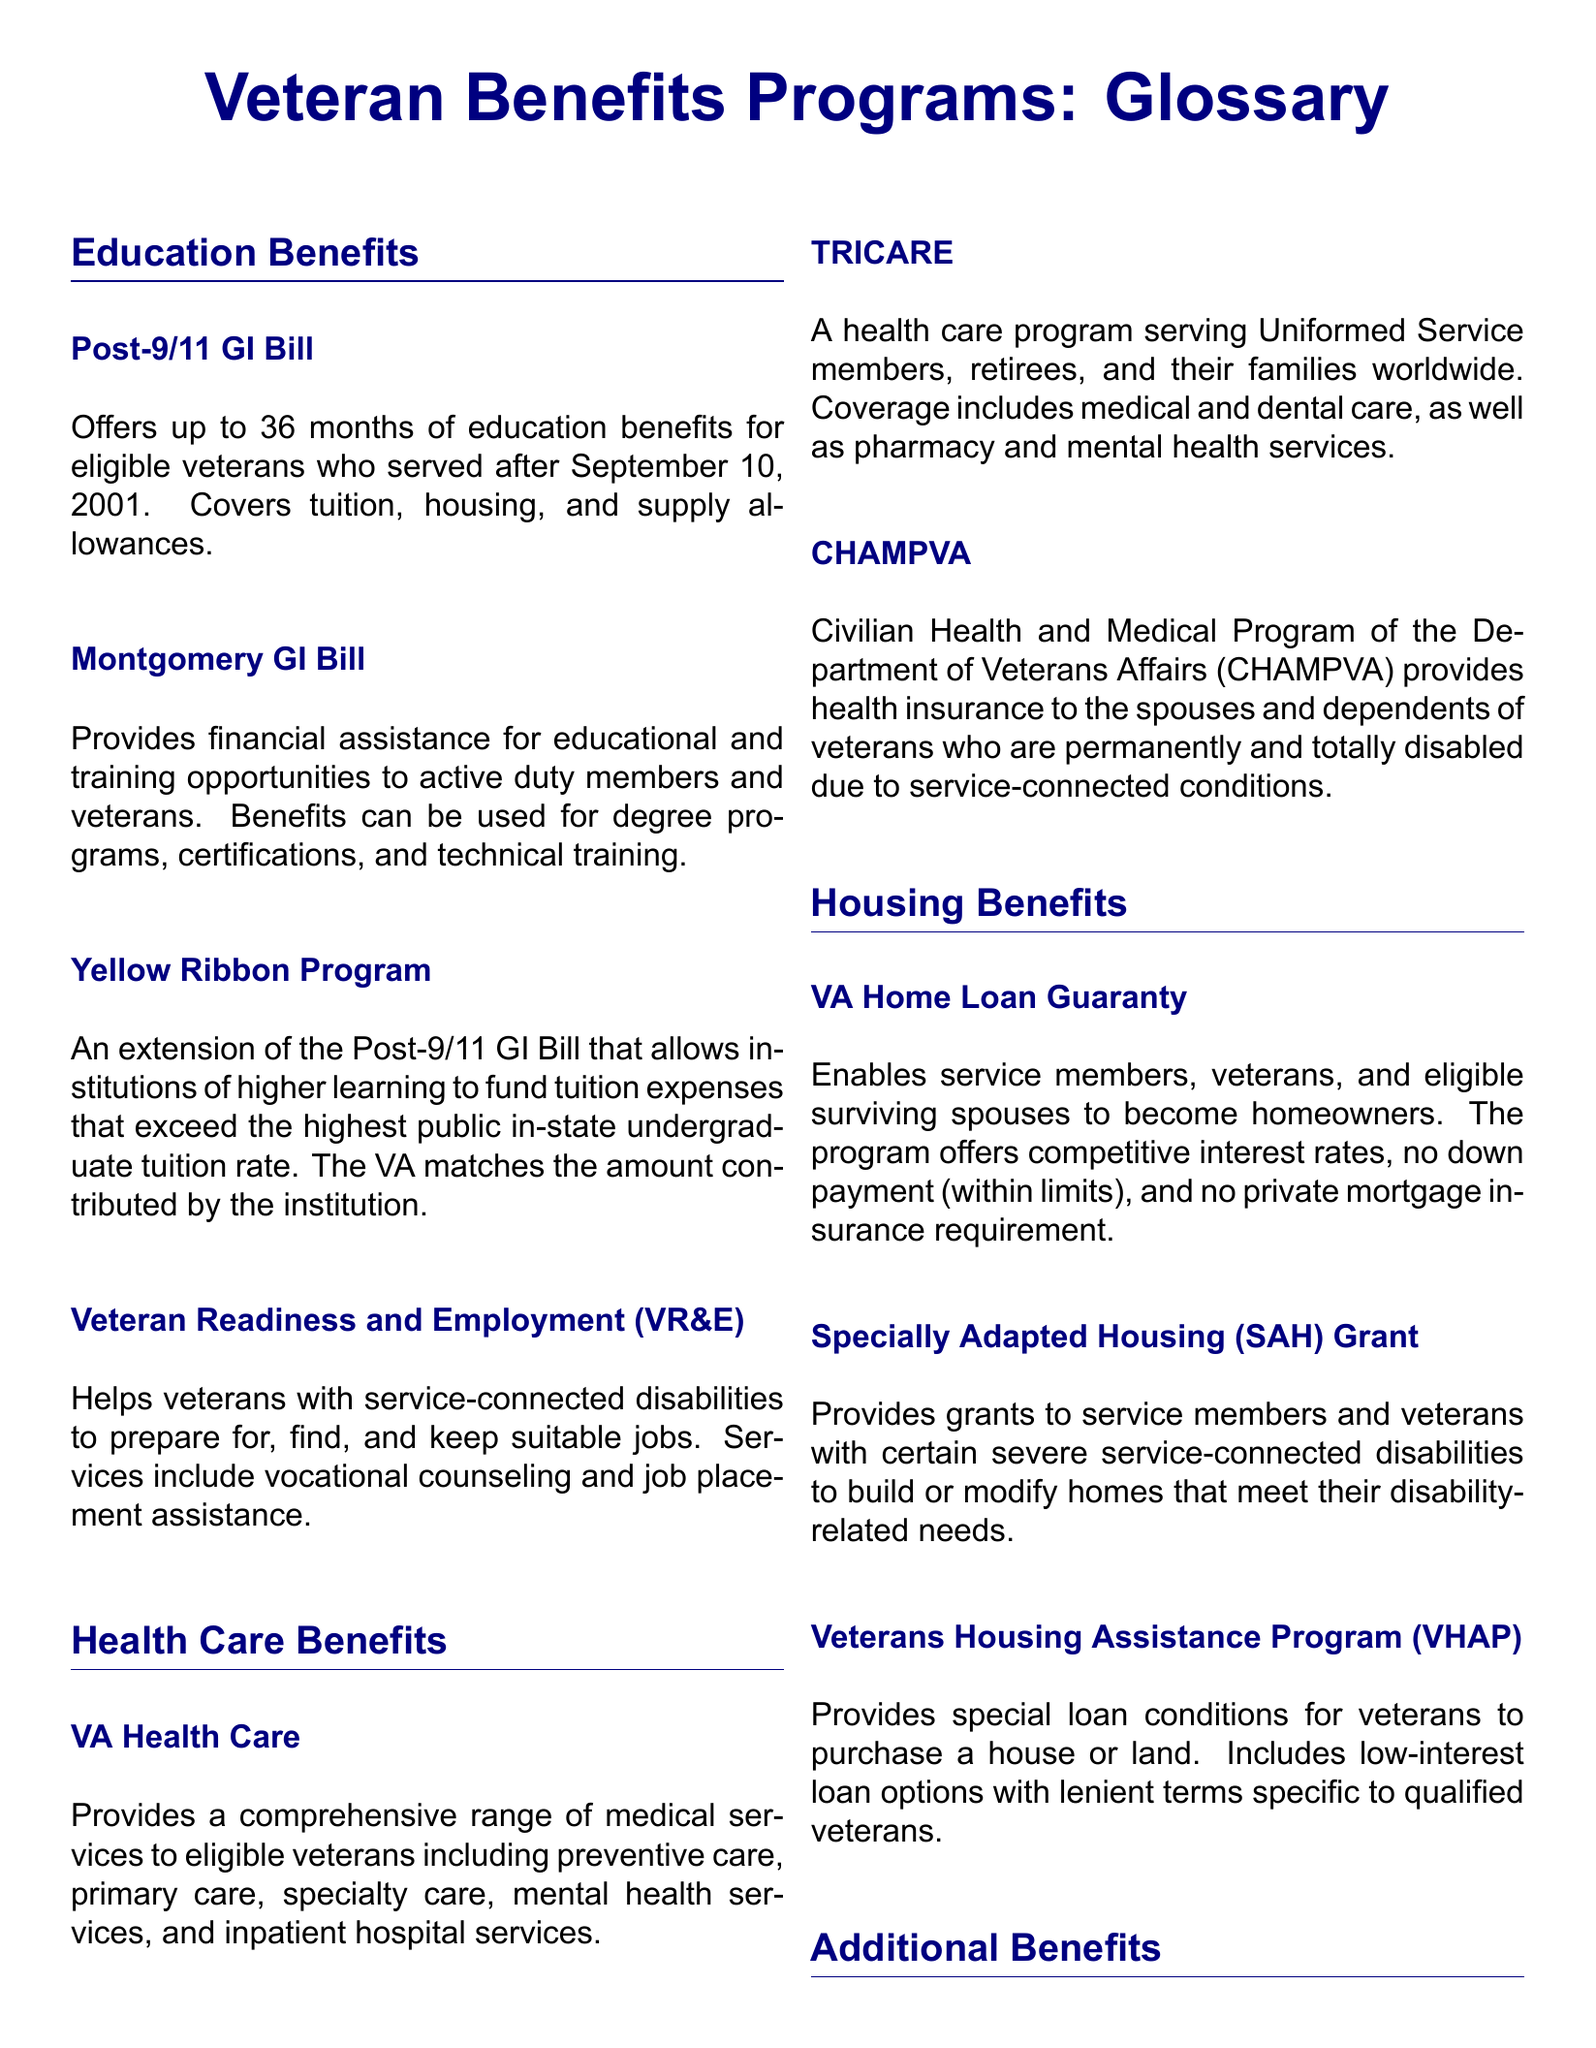What is the maximum duration of education benefits provided by the Post-9/11 GI Bill? The Post-9/11 GI Bill offers up to 36 months of education benefits for eligible veterans.
Answer: 36 months What type of assistance does the Veteran Readiness and Employment (VR&E) program provide? The VR&E program helps veterans with service-connected disabilities to prepare for, find, and keep suitable jobs.
Answer: Job placement assistance What is covered by CHAMPVA? CHAMPVA provides health insurance to the spouses and dependents of veterans who are permanently and totally disabled.
Answer: Health insurance Which program allows veterans to purchase homes with no down payment? The VA Home Loan Guaranty program enables veterans to become homeowners with no down payment (within limits).
Answer: VA Home Loan Guaranty What financial benefit is offered to low-income veterans aged 65 and older? The Pension program provides financial assistance to low-income veterans who are aged 65 and older.
Answer: Pension How does the Yellow Ribbon Program relate to the Post-9/11 GI Bill? The Yellow Ribbon Program is an extension of the Post-9/11 GI Bill, allowing institutions to fund tuition expenses that exceed certain limits.
Answer: Extension of the Post-9/11 GI Bill What type of grant is provided for veterans with severe service-connected disabilities? The Specially Adapted Housing (SAH) Grant provides grants to veterans with certain severe service-connected disabilities.
Answer: SAH Grant Who is eligible for disability compensation? Veterans with disabilities resulting from a disease or injury incurred or aggravated during active military service are eligible.
Answer: Veterans with disabilities What is the purpose of the Burial Benefits? Burial Benefits cover burial and funeral costs for eligible veterans, as well as burial in a VA national cemetery.
Answer: Burial and funeral costs 